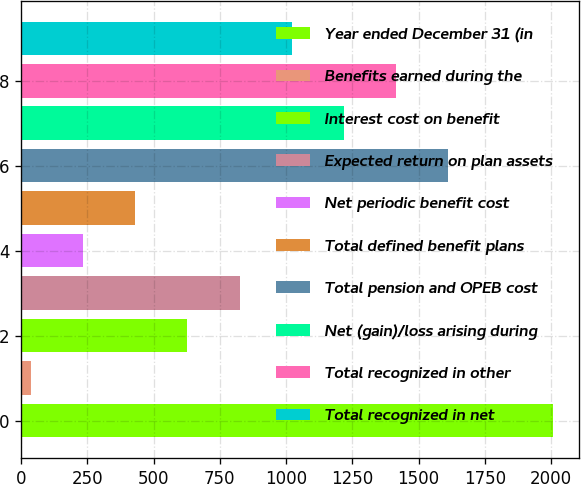Convert chart to OTSL. <chart><loc_0><loc_0><loc_500><loc_500><bar_chart><fcel>Year ended December 31 (in<fcel>Benefits earned during the<fcel>Interest cost on benefit<fcel>Expected return on plan assets<fcel>Net periodic benefit cost<fcel>Total defined benefit plans<fcel>Total pension and OPEB cost<fcel>Net (gain)/loss arising during<fcel>Total recognized in other<fcel>Total recognized in net<nl><fcel>2007<fcel>36<fcel>627.3<fcel>824.4<fcel>233.1<fcel>430.2<fcel>1612.8<fcel>1218.6<fcel>1415.7<fcel>1021.5<nl></chart> 